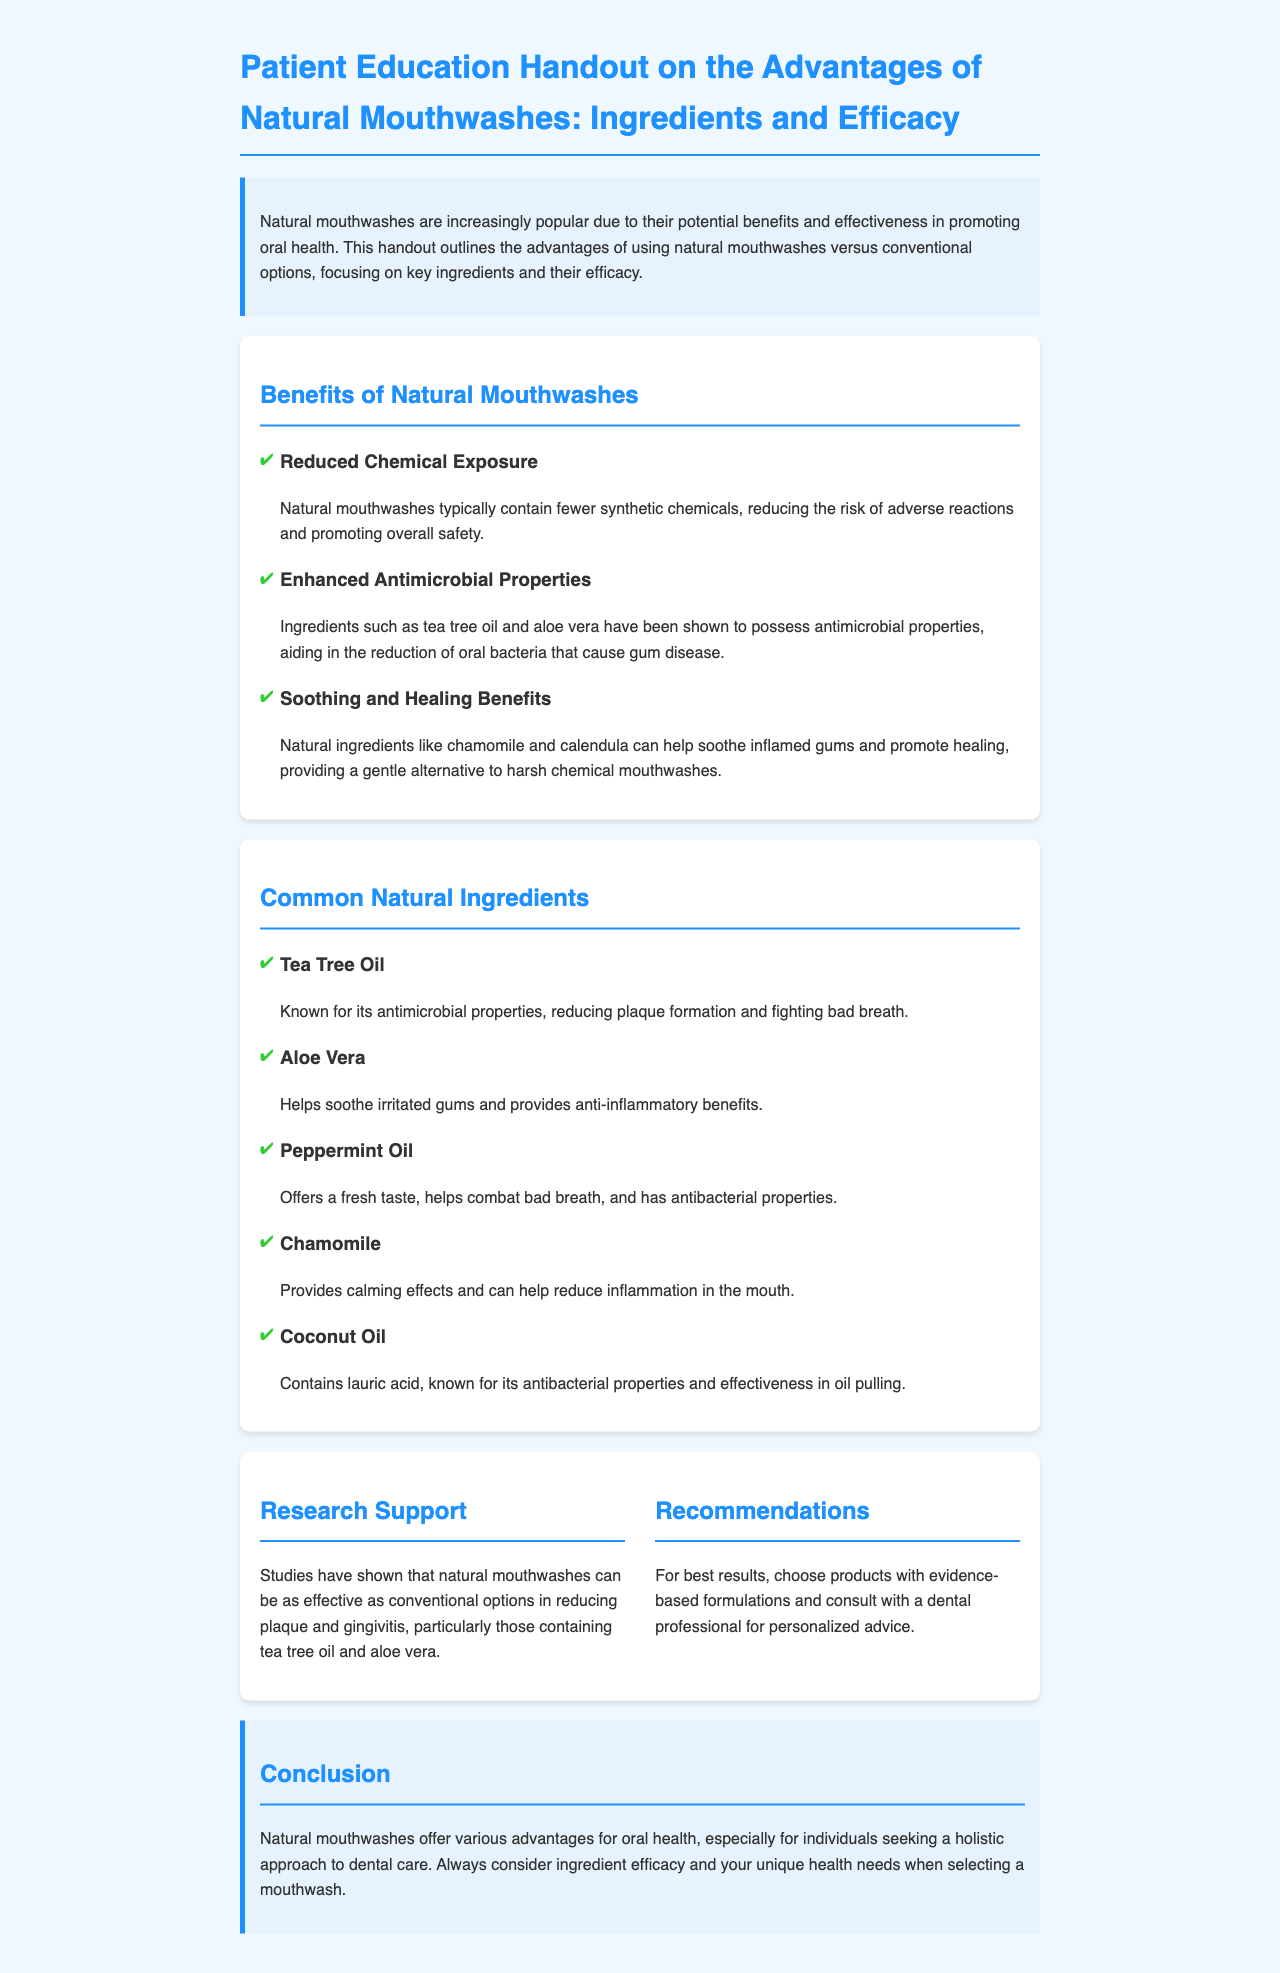What is the main focus of the handout? The handout outlines the advantages of using natural mouthwashes versus conventional options.
Answer: Advantages of using natural mouthwashes What is one benefit of natural mouthwashes? One of the benefits mentioned is reduced chemical exposure.
Answer: Reduced chemical exposure Which ingredient is known for its antimicrobial properties? Tea tree oil is specifically mentioned for its antimicrobial properties.
Answer: Tea tree oil How many common natural ingredients are listed? There are five common natural ingredients listed in the document.
Answer: Five According to the research support section, what is one effect of natural mouthwashes? Natural mouthwashes can be as effective as conventional options in reducing plaque and gingivitis.
Answer: Reducing plaque and gingivitis What ingredient helps soothe irritated gums? Aloe vera is known to help soothe irritated gums.
Answer: Aloe vera What is recommended for best results with natural mouthwashes? For best results, it is recommended to choose products with evidence-based formulations.
Answer: Evidence-based formulations What type of mouthwashes offers a holistic approach to dental care? Natural mouthwashes offer a holistic approach to dental care.
Answer: Natural mouthwashes 